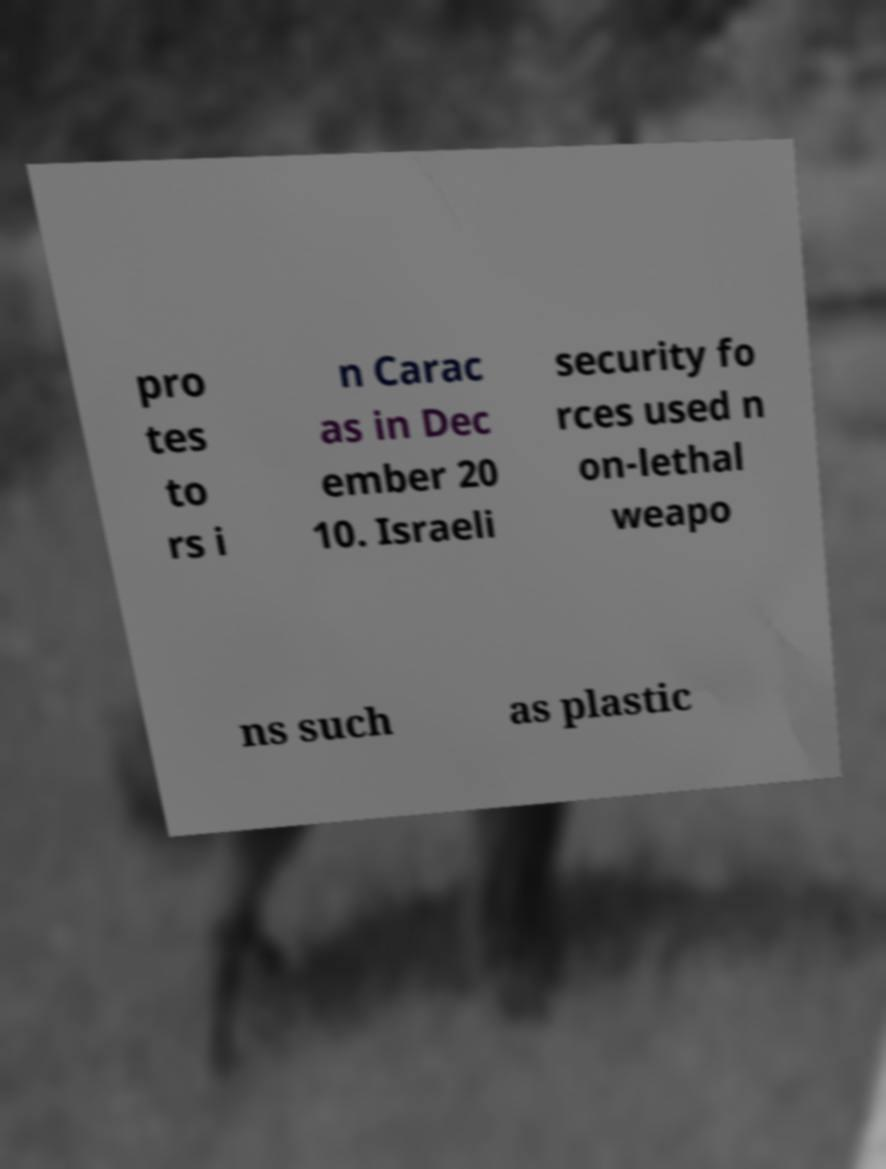Please read and relay the text visible in this image. What does it say? pro tes to rs i n Carac as in Dec ember 20 10. Israeli security fo rces used n on-lethal weapo ns such as plastic 